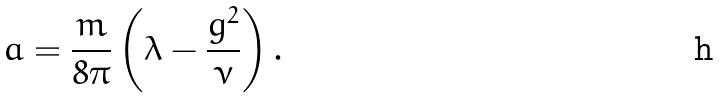<formula> <loc_0><loc_0><loc_500><loc_500>a = \frac { m } { 8 \pi } \left ( \lambda - \frac { g ^ { 2 } } { \nu } \right ) .</formula> 